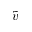<formula> <loc_0><loc_0><loc_500><loc_500>\tilde { v }</formula> 